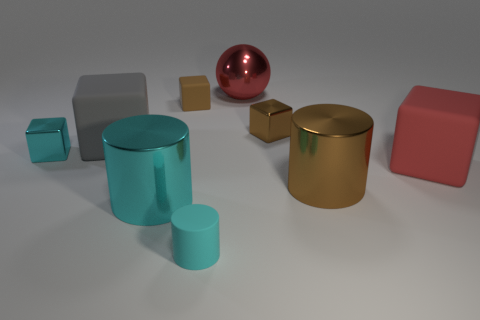How many objects are there in total in this image? In this image, there appears to be a total of eight objects, each with a distinct shape and color, creating a visually diverse tableau. 